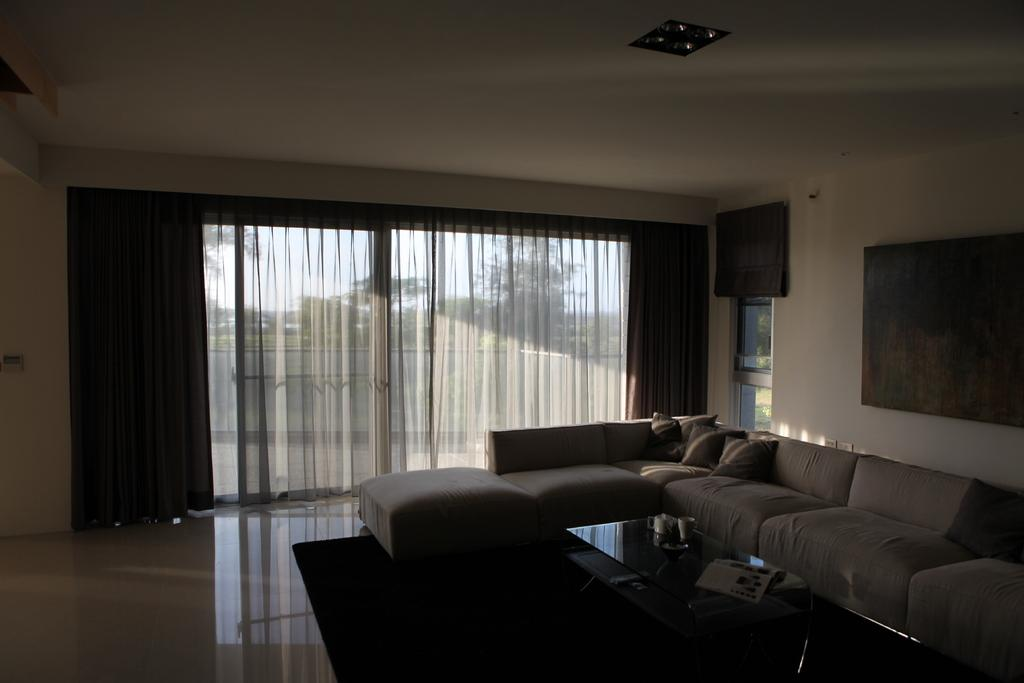What type of space is depicted in the image? There is a room in the image. What furniture is present in the room? There is a sofa with pillows in the room. What items can be seen on the table in the room? There are cups and papers on the table. What type of window treatment is present in the room? There are windows with curtains in the room. What decorative elements are on the wall in the room? There are frames on the wall. What type of root can be seen growing through the floor in the image? There is no root growing through the floor in the image; it is a room with a sofa, table, and other items. 